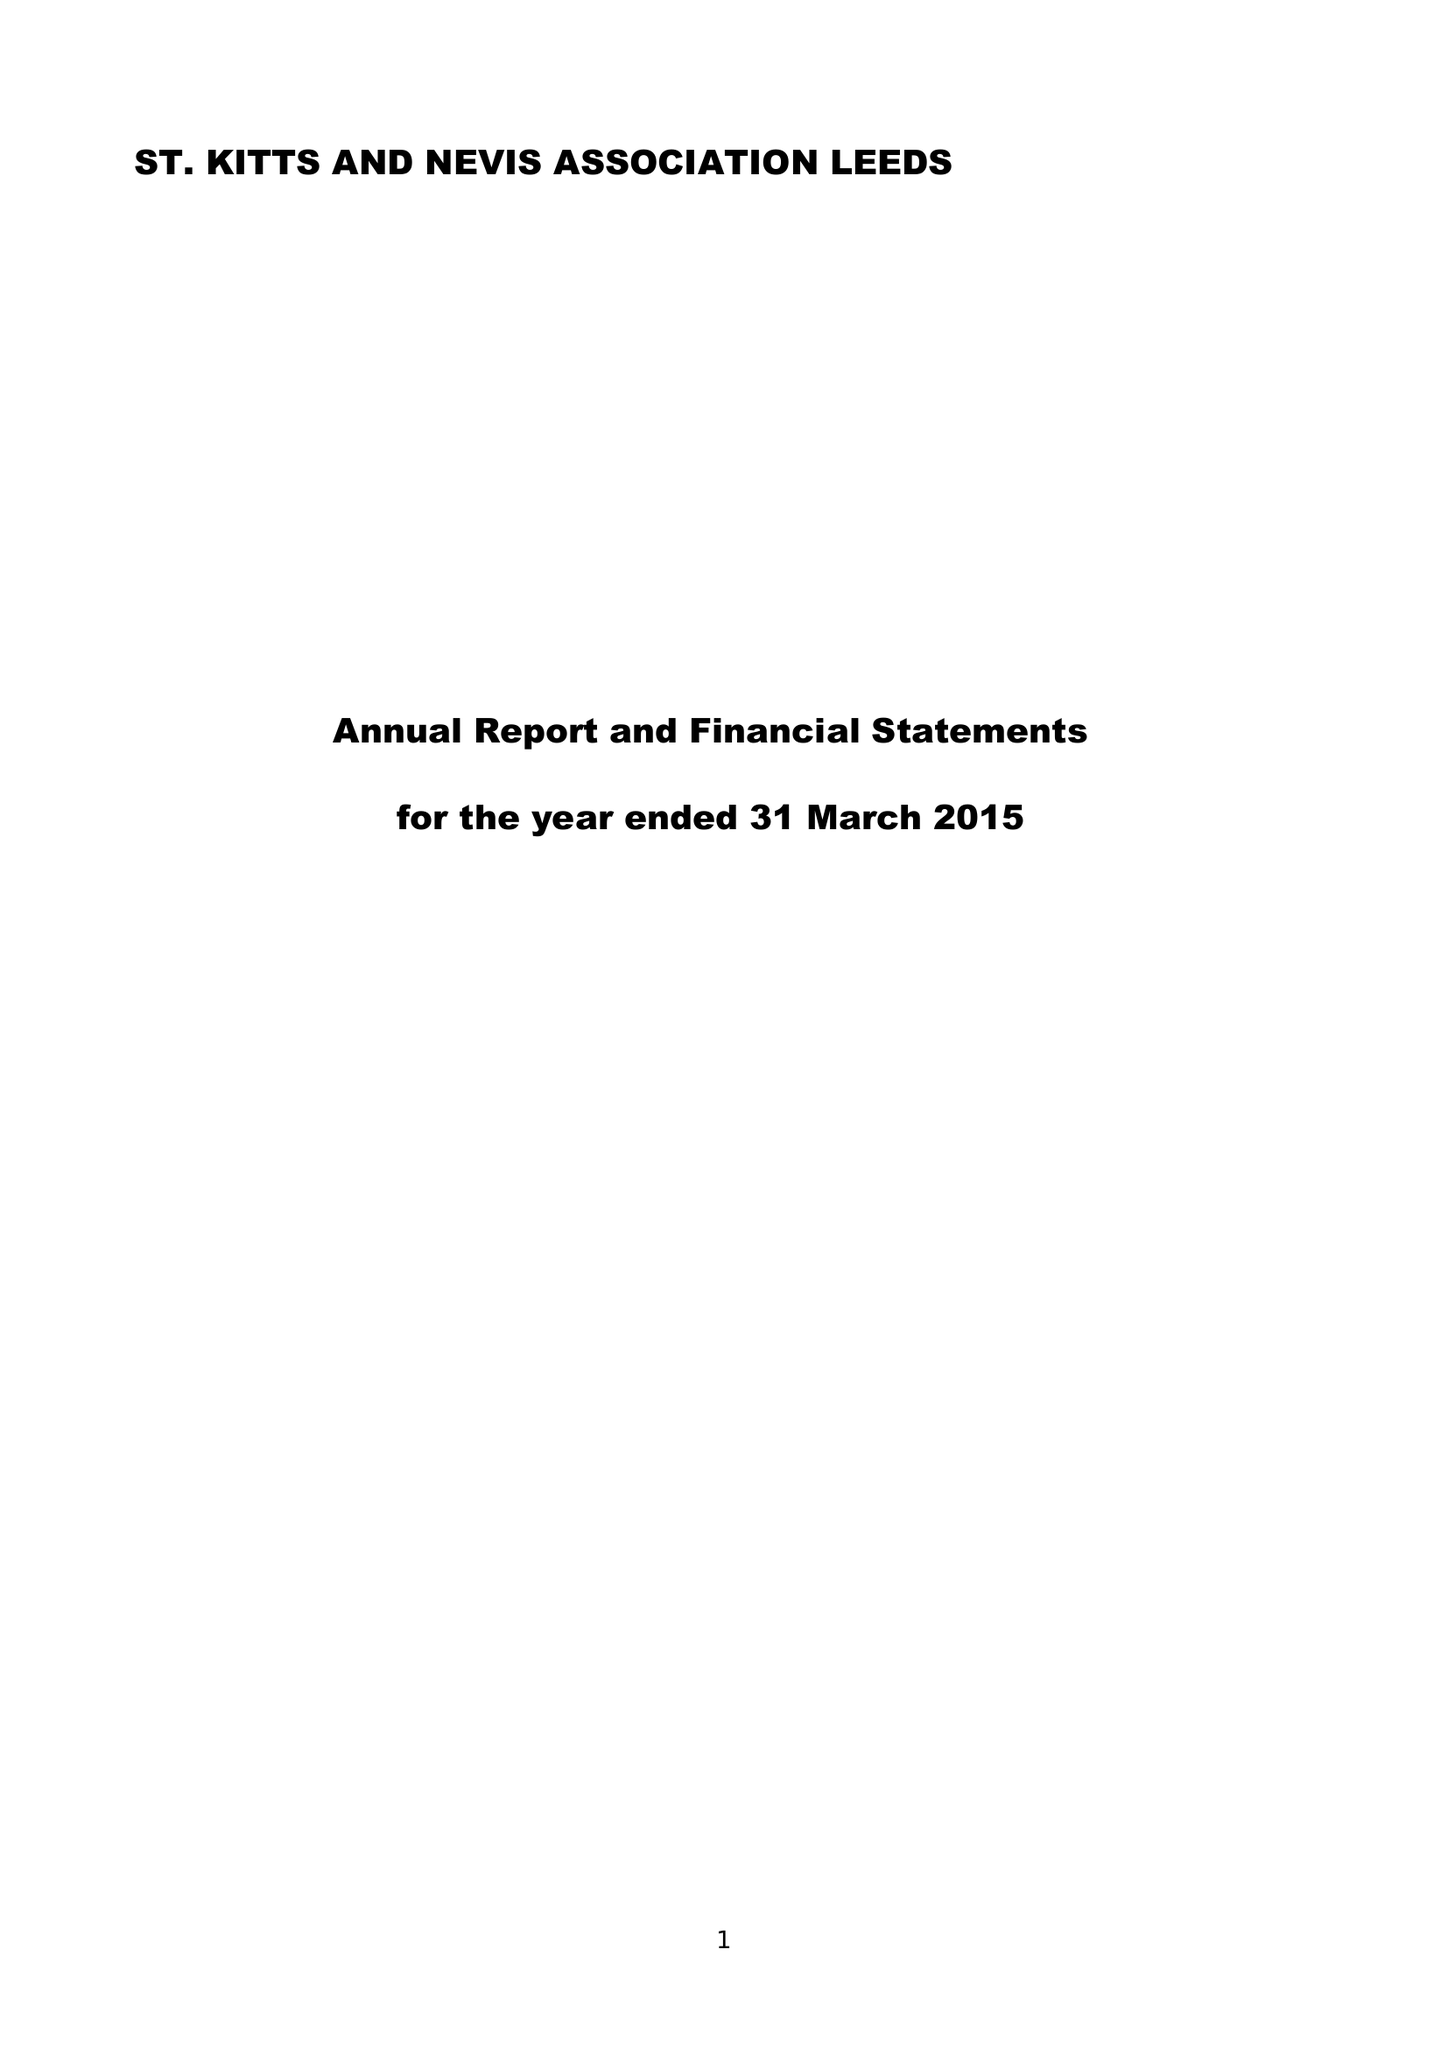What is the value for the address__street_line?
Answer the question using a single word or phrase. 80 SHEEPSCAR STREET NORTH 